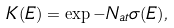<formula> <loc_0><loc_0><loc_500><loc_500>K ( E ) = \exp { - N _ { a t } \sigma ( E ) } ,</formula> 